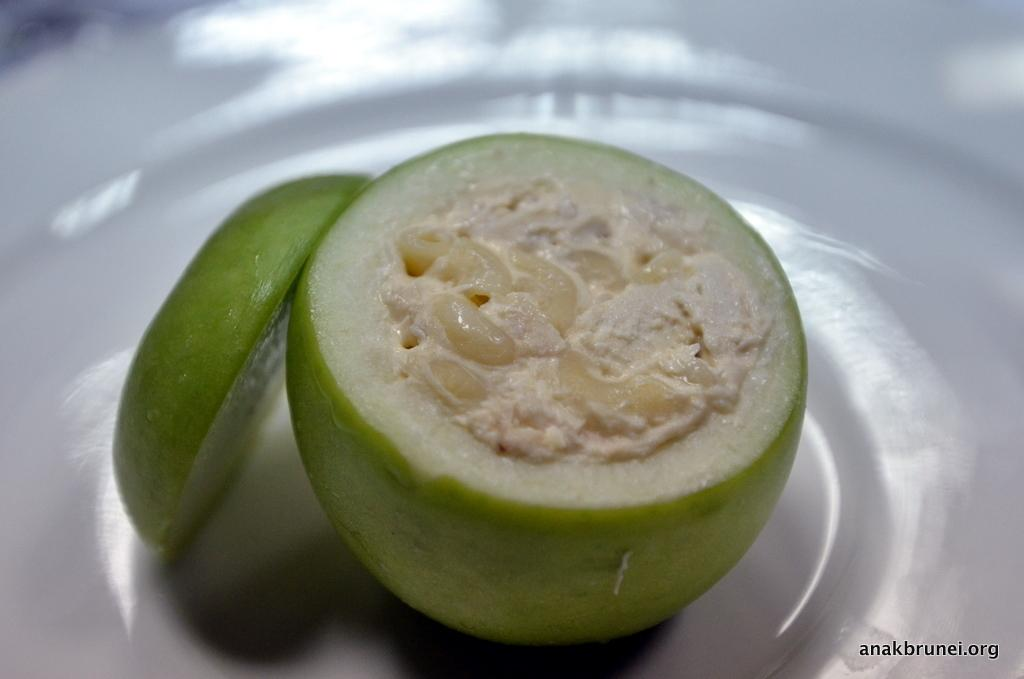What is on the plate that is visible in the image? The plate contains a fruit in the image. What is unique about the fruit on the plate? The fruit has food stuffed inside it. Can you describe the fruit on the plate in more detail? There is a slice of the fruit on the plate. What type of scarf is wrapped around the fruit in the image? There is no scarf present in the image; the fruit has food stuffed inside it. How many sticks are used to hold the fruit in place on the plate? There are no sticks visible in the image; the fruit is simply placed on the plate. 